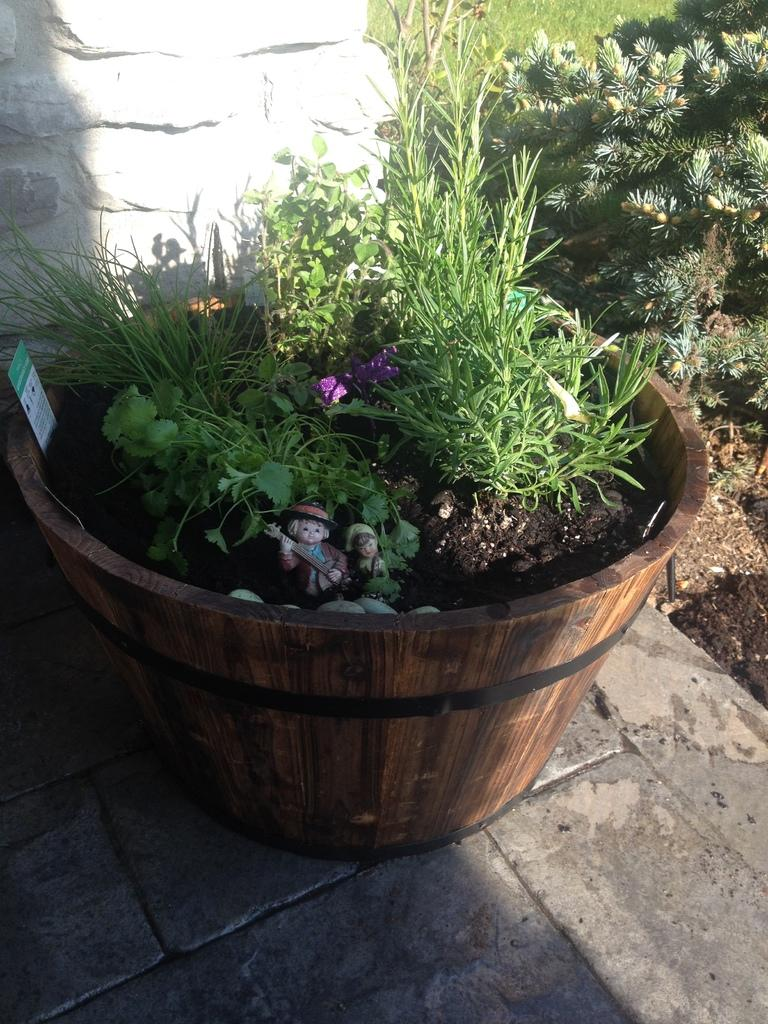What type of container is the house plant in? The house plant is in a wooden bowl in the image. Are there any other plants visible in the image? Yes, there are other plants visible in the image. What part of a plant can be seen in the image? A part of a grass is present in the image. Can you tell me how many times the ghost sneezes in the image? There is no ghost present in the image, and therefore no sneezing can be observed. 